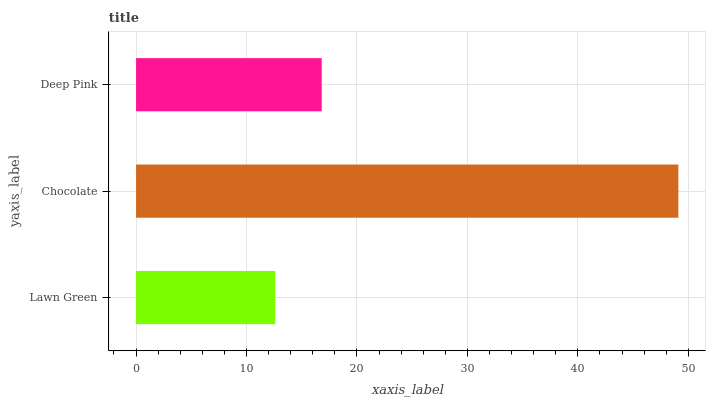Is Lawn Green the minimum?
Answer yes or no. Yes. Is Chocolate the maximum?
Answer yes or no. Yes. Is Deep Pink the minimum?
Answer yes or no. No. Is Deep Pink the maximum?
Answer yes or no. No. Is Chocolate greater than Deep Pink?
Answer yes or no. Yes. Is Deep Pink less than Chocolate?
Answer yes or no. Yes. Is Deep Pink greater than Chocolate?
Answer yes or no. No. Is Chocolate less than Deep Pink?
Answer yes or no. No. Is Deep Pink the high median?
Answer yes or no. Yes. Is Deep Pink the low median?
Answer yes or no. Yes. Is Chocolate the high median?
Answer yes or no. No. Is Chocolate the low median?
Answer yes or no. No. 